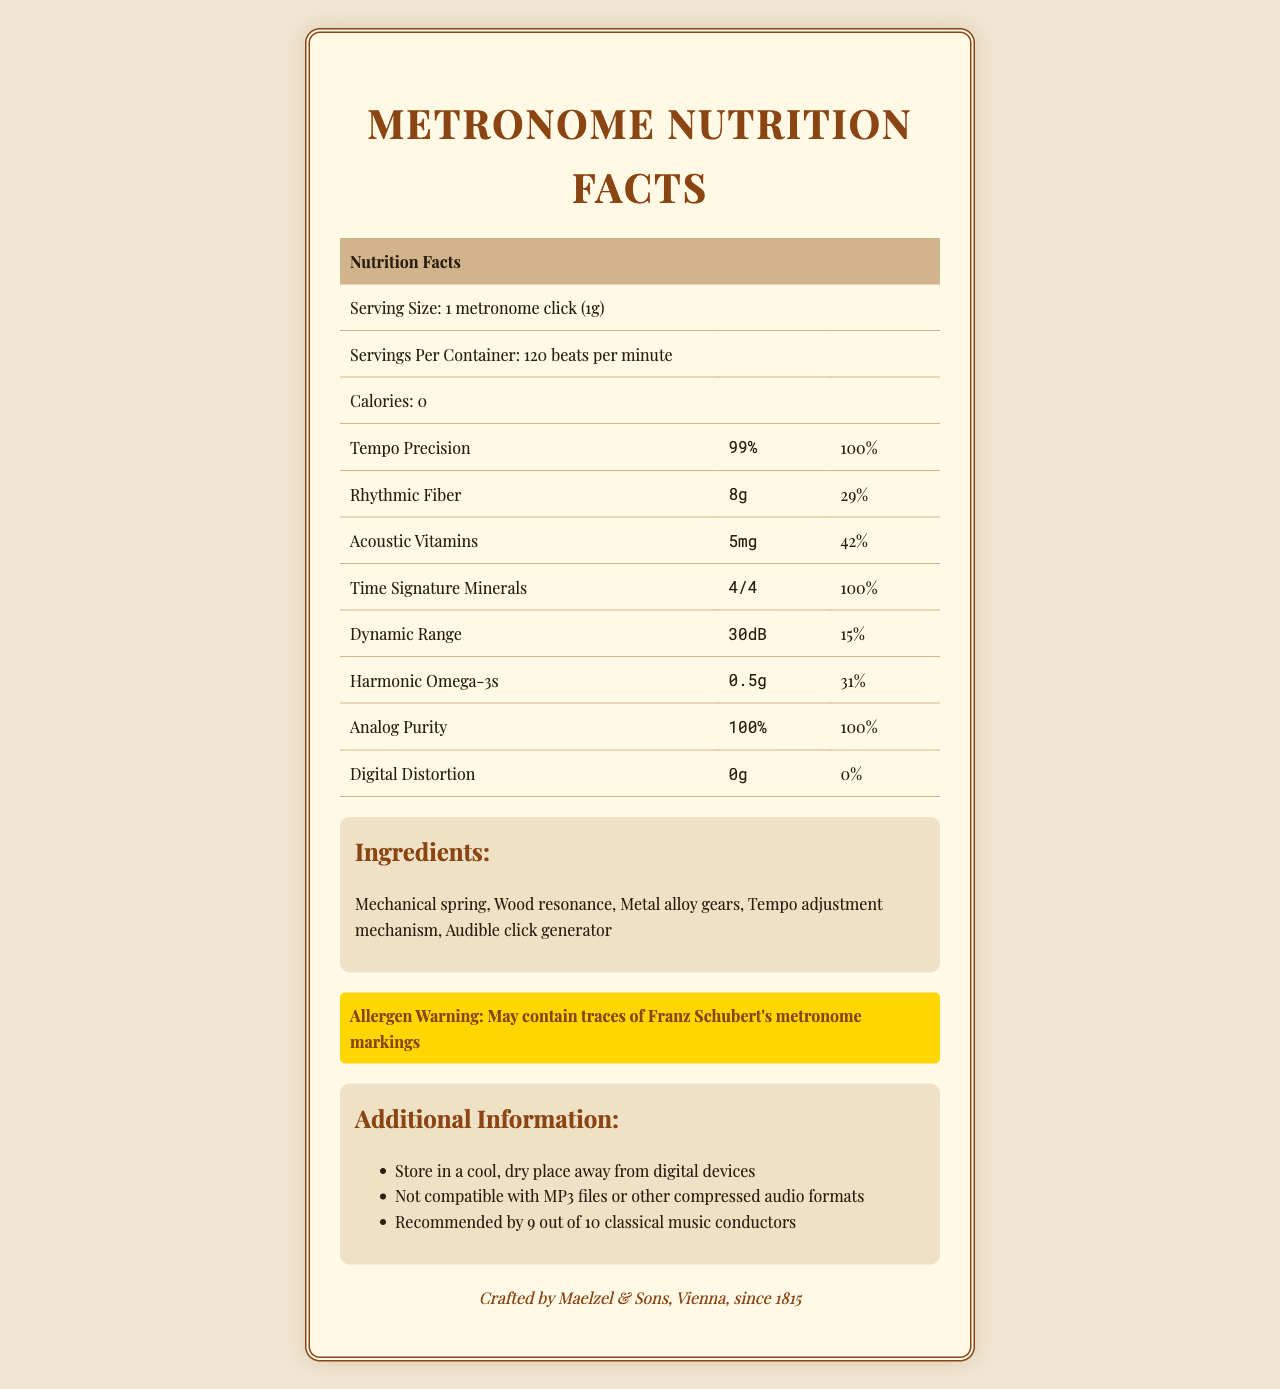what is the serving size of the metronome? The document explicitly states that the serving size is "1 metronome click (1g)."
Answer: 1 metronome click (1g) how many servings per container are there? The document mentions that there are "120 beats per minute" per container.
Answer: 120 beats per minute How many calories are in one serving of the metronome? The document states that the calories per serving are 0.
Answer: 0 what is the percentage of daily value for Tempo Precision? The document lists the daily value percentage for Tempo Precision as 100%.
Answer: 100% how much Rhythmic Fiber is in one serving? According to the document, there are 8g of Rhythmic Fiber per serving.
Answer: 8g Which nutrient has the smallest amount per serving? A. Tempo Precision B. Acoustic Vitamins C. Harmonic Omega-3s D. Dynamic Range Acoustic Vitamins have the smallest amount per serving, listed as 5mg.
Answer: B. Acoustic Vitamins Which is one of the ingredients in the metronome? A. Plastic casing B. Metal alloy gears C. Rubber padding The document lists "Metal alloy gears" as one of the ingredients.
Answer: B. Metal alloy gears Is the metronome compatible with MP3 files? The additional info section states, "Not compatible with MP3 files or other compressed audio formats."
Answer: No What is the daily value percentage of Harmonic Omega-3s? The document reports a daily value percentage of 31% for Harmonic Omega-3s.
Answer: 31% Provide a summary of the document. The document mimics a Nutrition Facts Label, providing whimsical information as if the metronome were a consumable product.
Answer: The document details the "nutritional" profile of a metronome, listing various "nutrients" like Tempo Precision and Rhythmic Fiber along with their amounts and daily values. It also lists calories (none), serving size, servings per container, and ingredients. Additional info includes its storage recommendations, compatibility issues with MP3 files, and a manufacturer note. what is the recommended storage condition for the metronome? The additional info segment advises storing the metronome in a cool, dry place away from digital devices.
Answer: Store in a cool, dry place away from digital devices Who manufactures the metronome? The manufacturer information at the end of the document states that it is crafted by Maelzel & Sons, Vienna, since 1815.
Answer: Maelzel & Sons, Vienna, since 1815 What is the amount (in decibels) of Dynamic Range? The document lists Dynamic Range as 30dB.
Answer: 30dB How much Acoustic Vitamins does a serving provide? A. 5mg B. 15mg C. 42mg D. 8g The document specifies Acoustic Vitamins at an amount of 5mg per serving.
Answer: A. 5mg Does the metronome contain any Digital Distortion? The nutritional content for Digital Distortion is listed as 0g, implying none present.
Answer: No What types of questions did the classical music conductors recommend? The document states that the metronome is "recommended by 9 out of 10 classical music conductors" but does not specify which types of questions.
Answer: Cannot be determined 